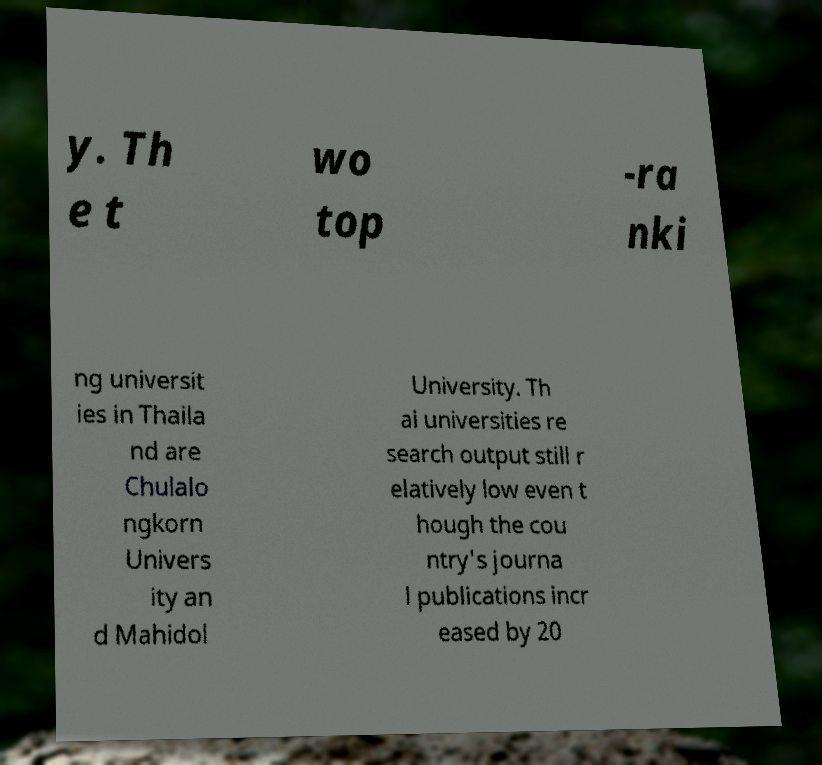Could you extract and type out the text from this image? y. Th e t wo top -ra nki ng universit ies in Thaila nd are Chulalo ngkorn Univers ity an d Mahidol University. Th ai universities re search output still r elatively low even t hough the cou ntry's journa l publications incr eased by 20 